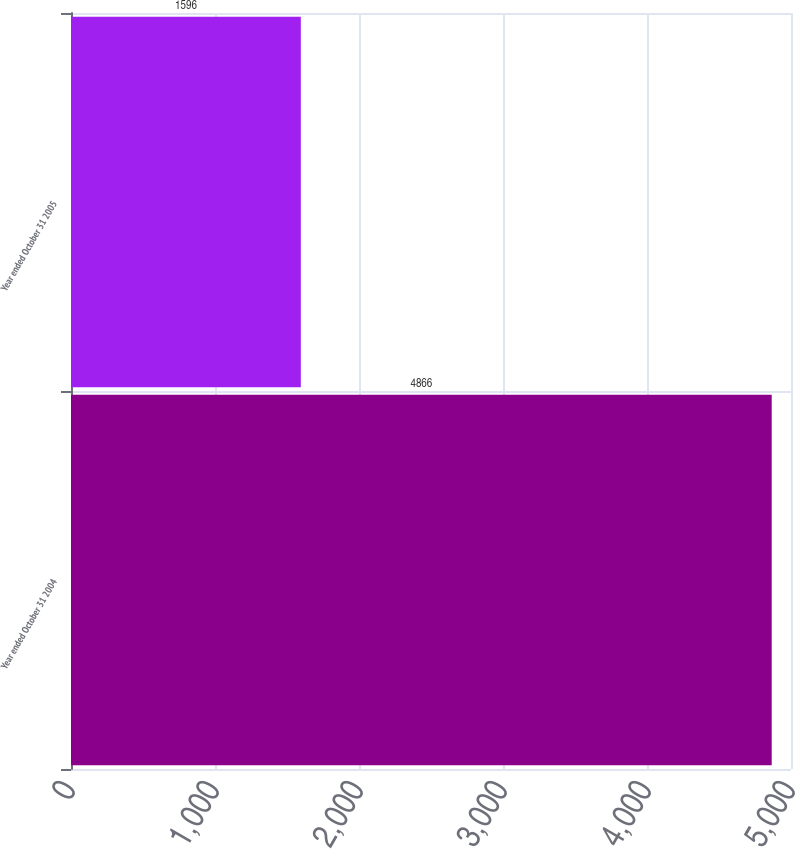<chart> <loc_0><loc_0><loc_500><loc_500><bar_chart><fcel>Year ended October 31 2004<fcel>Year ended October 31 2005<nl><fcel>4866<fcel>1596<nl></chart> 